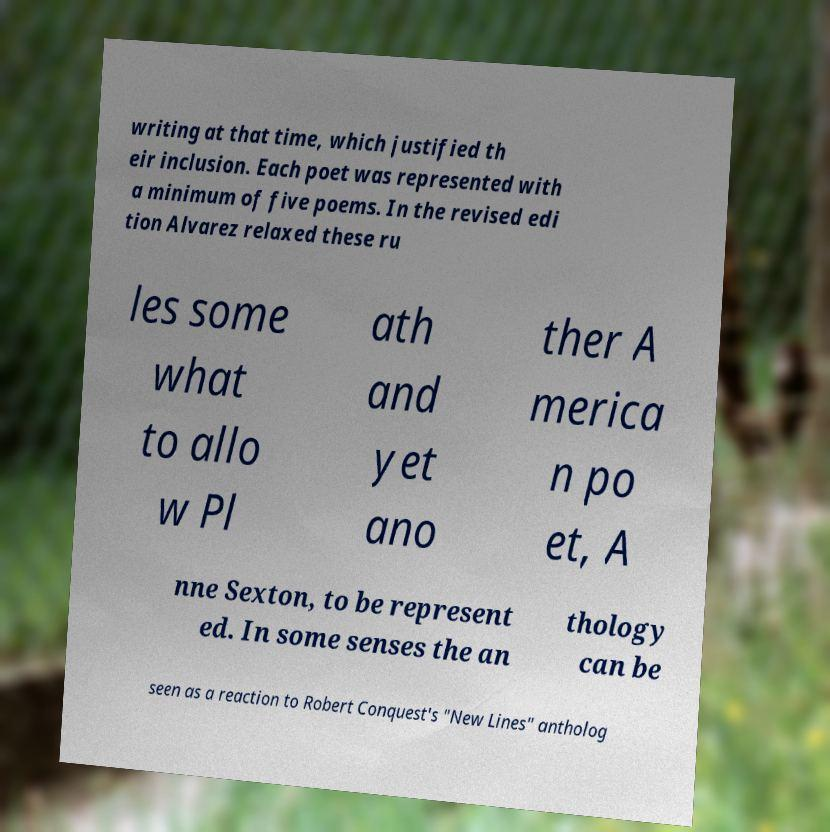Could you assist in decoding the text presented in this image and type it out clearly? writing at that time, which justified th eir inclusion. Each poet was represented with a minimum of five poems. In the revised edi tion Alvarez relaxed these ru les some what to allo w Pl ath and yet ano ther A merica n po et, A nne Sexton, to be represent ed. In some senses the an thology can be seen as a reaction to Robert Conquest's "New Lines" antholog 